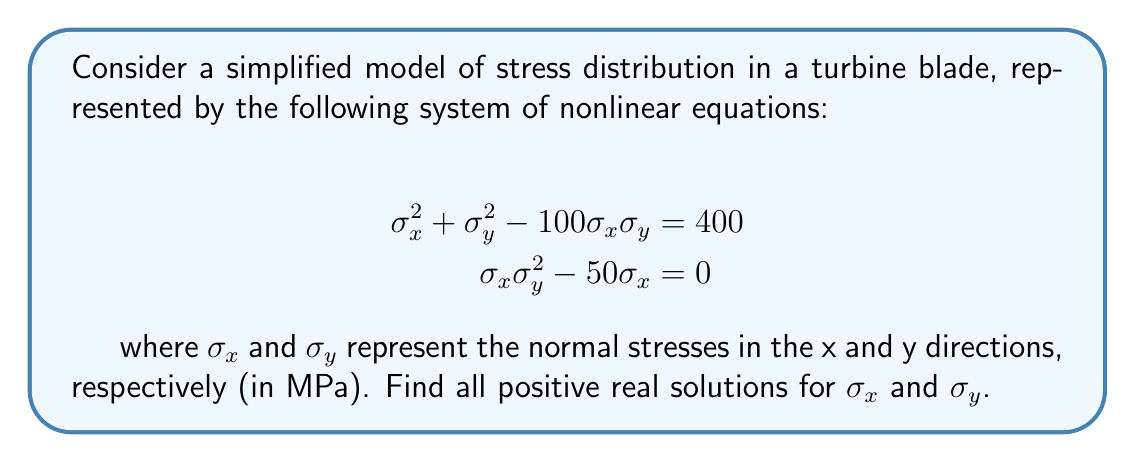Provide a solution to this math problem. Let's solve this system of nonlinear equations step by step:

1) From the second equation, we can factor out $\sigma_x$:
   $$\sigma_x(\sigma_y^2 - 50) = 0$$

2) This gives us two cases to consider:
   Case 1: $\sigma_x = 0$
   Case 2: $\sigma_y^2 - 50 = 0$

3) Let's start with Case 2: $\sigma_y^2 - 50 = 0$
   Solving this, we get: $\sigma_y = \pm \sqrt{50} = \pm 7.071$
   Since we're only interested in positive solutions, $\sigma_y \approx 7.071$

4) Substituting this value of $\sigma_y$ into the first equation:
   $$\sigma_x^2 + (7.071)^2 - 100\sigma_x(7.071) = 400$$

5) Simplifying:
   $$\sigma_x^2 - 707.1\sigma_x + 350 = 0$$

6) This is a quadratic equation in $\sigma_x$. We can solve it using the quadratic formula:
   $$\sigma_x = \frac{707.1 \pm \sqrt{(707.1)^2 - 4(1)(350)}}{2(1)}$$

7) Simplifying:
   $$\sigma_x = \frac{707.1 \pm \sqrt{499984.41 - 1400}}{2} = \frac{707.1 \pm 706.1}{2}$$

8) This gives us two solutions:
   $$\sigma_x \approx 706.6 \text{ or } \sigma_x \approx 0.5$$

9) Checking Case 1 ($\sigma_x = 0$):
   Substituting into the first equation:
   $$0^2 + \sigma_y^2 - 100(0)(\sigma_y) = 400$$
   $$\sigma_y^2 = 400$$
   $$\sigma_y = 20$$

Therefore, we have three positive real solutions:
1) $\sigma_x \approx 706.6, \sigma_y \approx 7.071$
2) $\sigma_x \approx 0.5, \sigma_y \approx 7.071$
3) $\sigma_x = 0, \sigma_y = 20$
Answer: $(\sigma_x, \sigma_y) \approx (706.6, 7.071), (0.5, 7.071), (0, 20)$ 